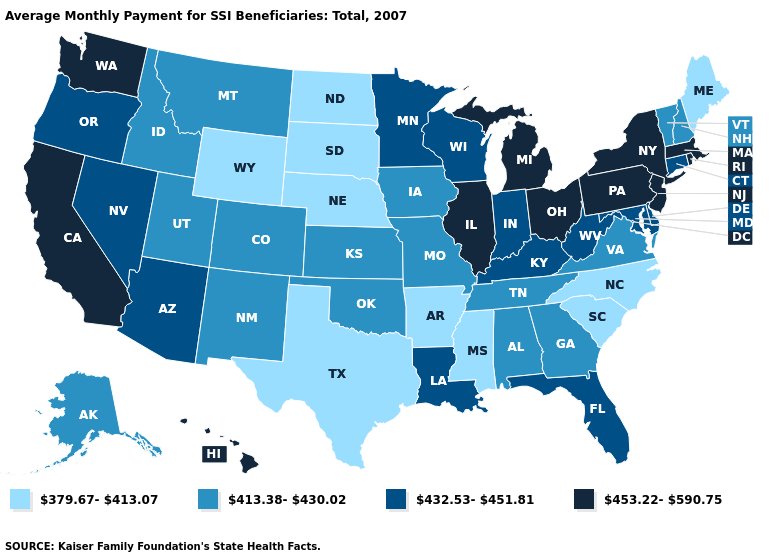What is the highest value in the USA?
Concise answer only. 453.22-590.75. Name the states that have a value in the range 432.53-451.81?
Short answer required. Arizona, Connecticut, Delaware, Florida, Indiana, Kentucky, Louisiana, Maryland, Minnesota, Nevada, Oregon, West Virginia, Wisconsin. What is the lowest value in states that border Nebraska?
Concise answer only. 379.67-413.07. Does Wyoming have the lowest value in the West?
Quick response, please. Yes. Does the first symbol in the legend represent the smallest category?
Give a very brief answer. Yes. What is the lowest value in the USA?
Write a very short answer. 379.67-413.07. Is the legend a continuous bar?
Concise answer only. No. Which states have the highest value in the USA?
Quick response, please. California, Hawaii, Illinois, Massachusetts, Michigan, New Jersey, New York, Ohio, Pennsylvania, Rhode Island, Washington. Does Arkansas have a lower value than Kentucky?
Quick response, please. Yes. Does the first symbol in the legend represent the smallest category?
Concise answer only. Yes. Is the legend a continuous bar?
Quick response, please. No. Does Florida have the highest value in the USA?
Quick response, please. No. Name the states that have a value in the range 379.67-413.07?
Keep it brief. Arkansas, Maine, Mississippi, Nebraska, North Carolina, North Dakota, South Carolina, South Dakota, Texas, Wyoming. Which states have the highest value in the USA?
Quick response, please. California, Hawaii, Illinois, Massachusetts, Michigan, New Jersey, New York, Ohio, Pennsylvania, Rhode Island, Washington. How many symbols are there in the legend?
Short answer required. 4. 